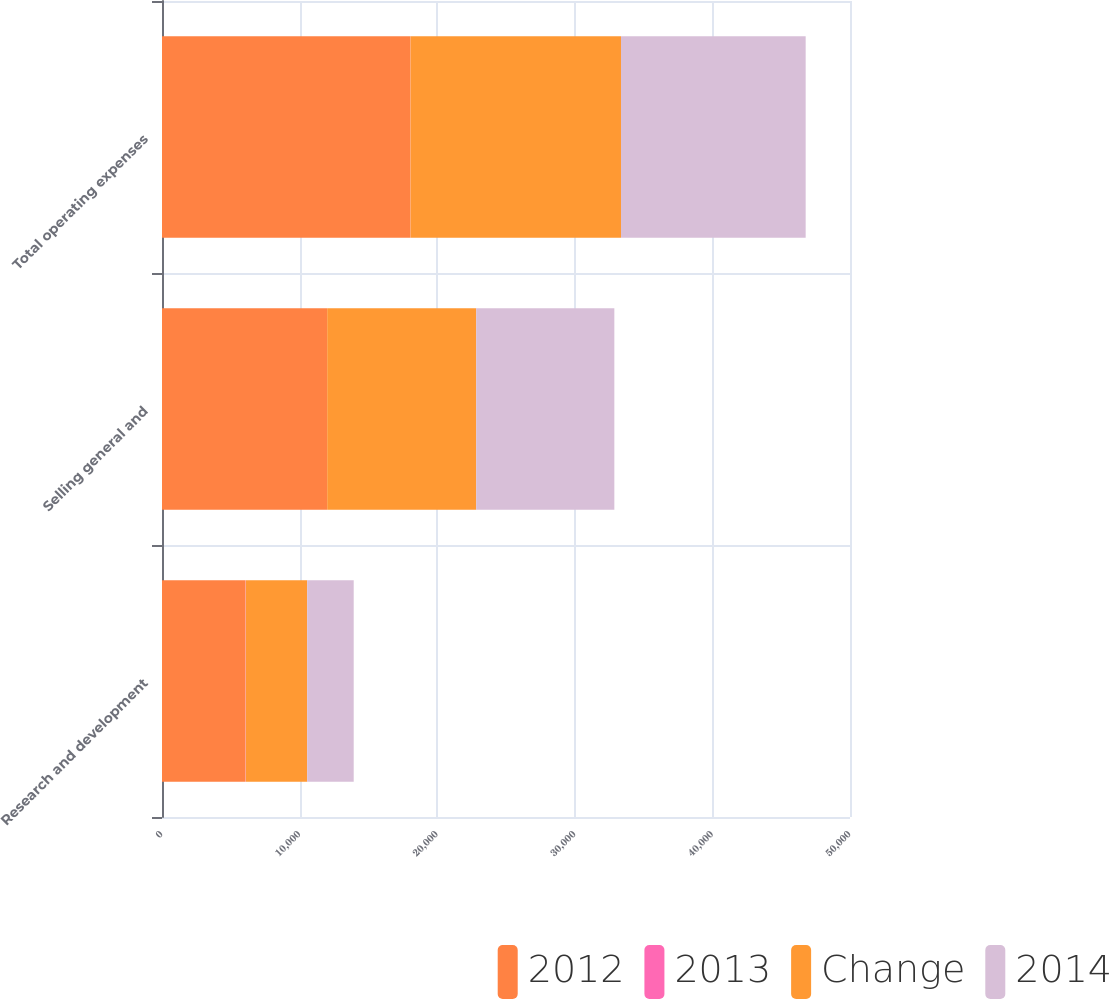Convert chart. <chart><loc_0><loc_0><loc_500><loc_500><stacked_bar_chart><ecel><fcel>Research and development<fcel>Selling general and<fcel>Total operating expenses<nl><fcel>2012<fcel>6041<fcel>11993<fcel>18034<nl><fcel>2013<fcel>35<fcel>11<fcel>18<nl><fcel>Change<fcel>4475<fcel>10830<fcel>15305<nl><fcel>2014<fcel>3381<fcel>10040<fcel>13421<nl></chart> 